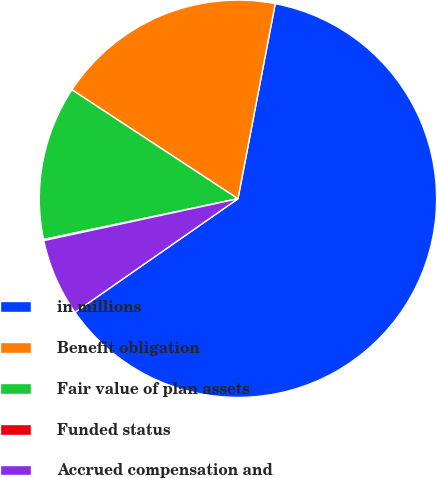Convert chart. <chart><loc_0><loc_0><loc_500><loc_500><pie_chart><fcel>in millions<fcel>Benefit obligation<fcel>Fair value of plan assets<fcel>Funded status<fcel>Accrued compensation and<nl><fcel>62.3%<fcel>18.76%<fcel>12.53%<fcel>0.09%<fcel>6.31%<nl></chart> 